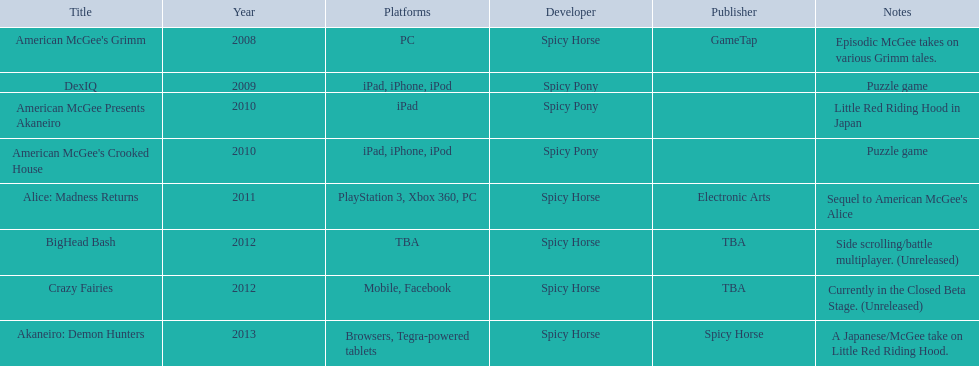What are all the designations of games released? American McGee's Grimm, DexIQ, American McGee Presents Akaneiro, American McGee's Crooked House, Alice: Madness Returns, BigHead Bash, Crazy Fairies, Akaneiro: Demon Hunters. What are all the appellations of the publishers? GameTap, , , , Electronic Arts, TBA, TBA, Spicy Horse. What is the issued game title that corresponds to electronic arts? Alice: Madness Returns. 